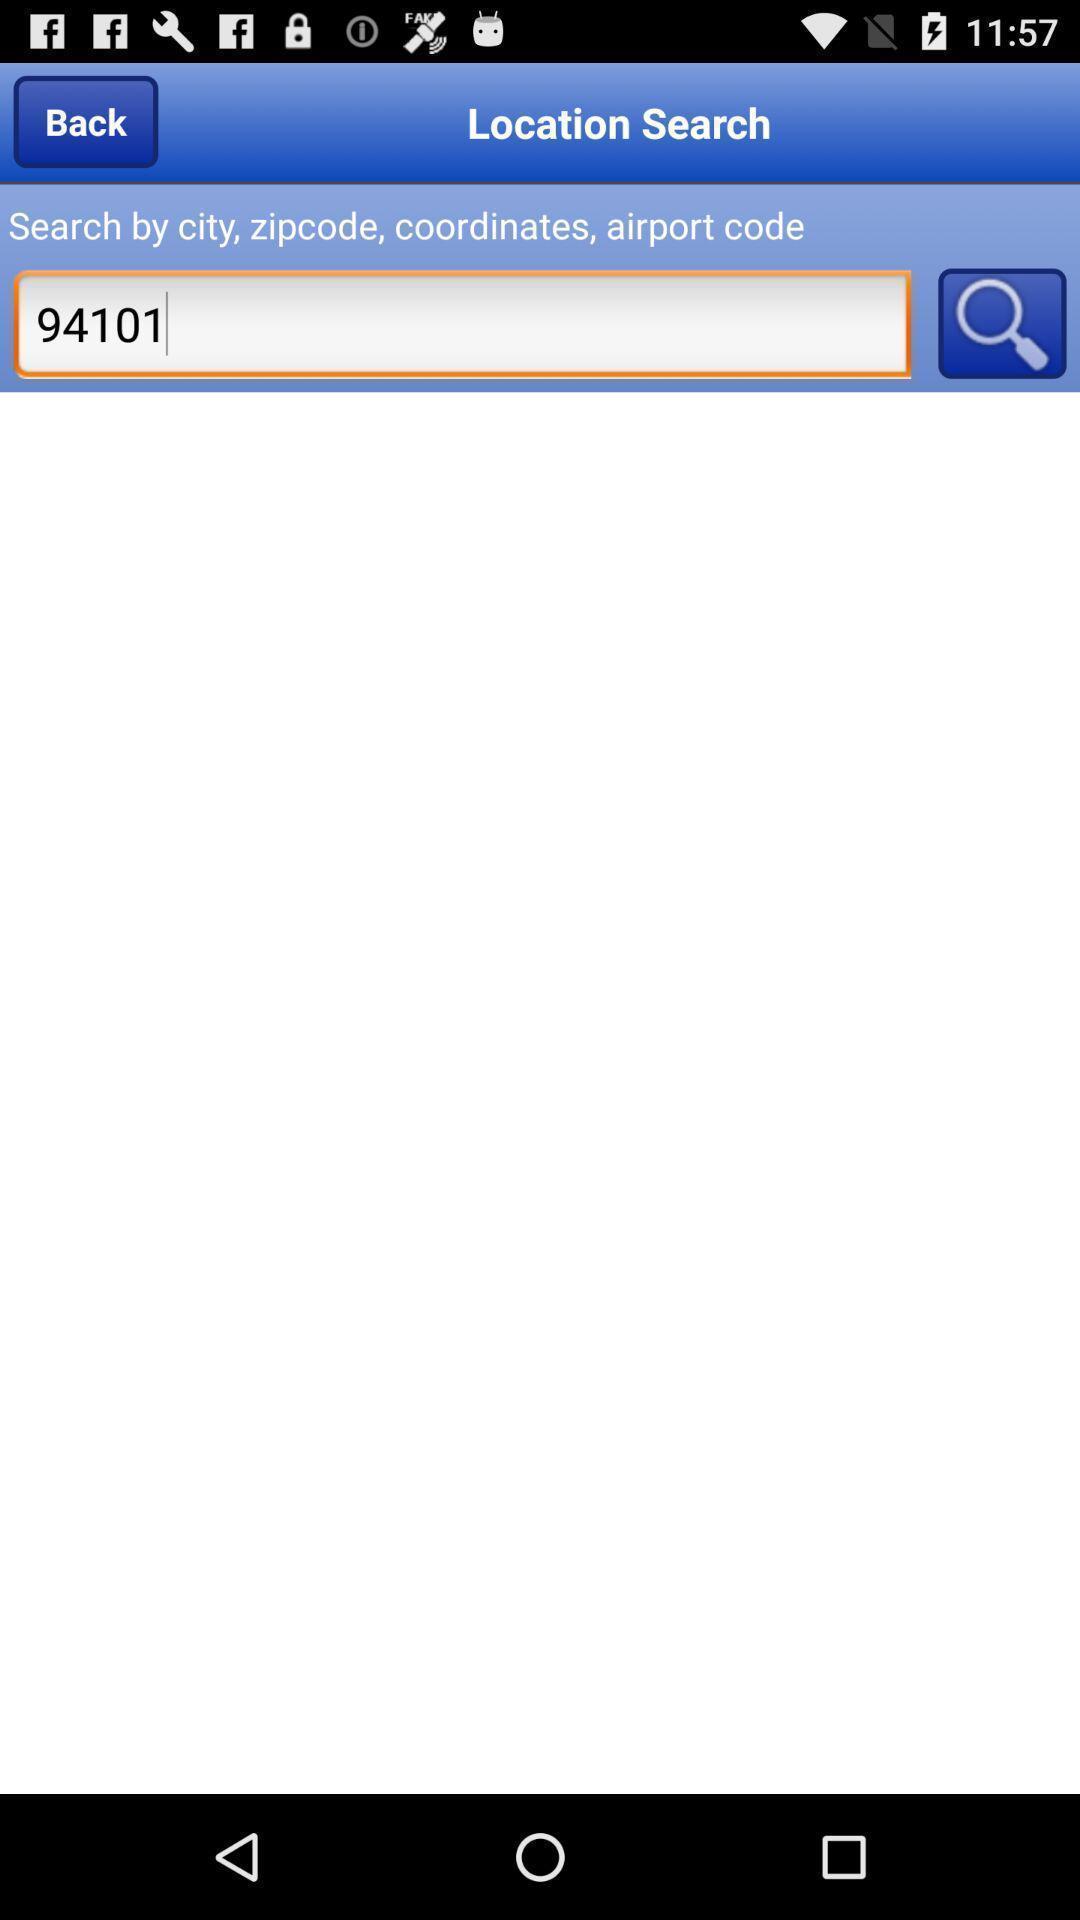Tell me what you see in this picture. Window displaying is to search location. 